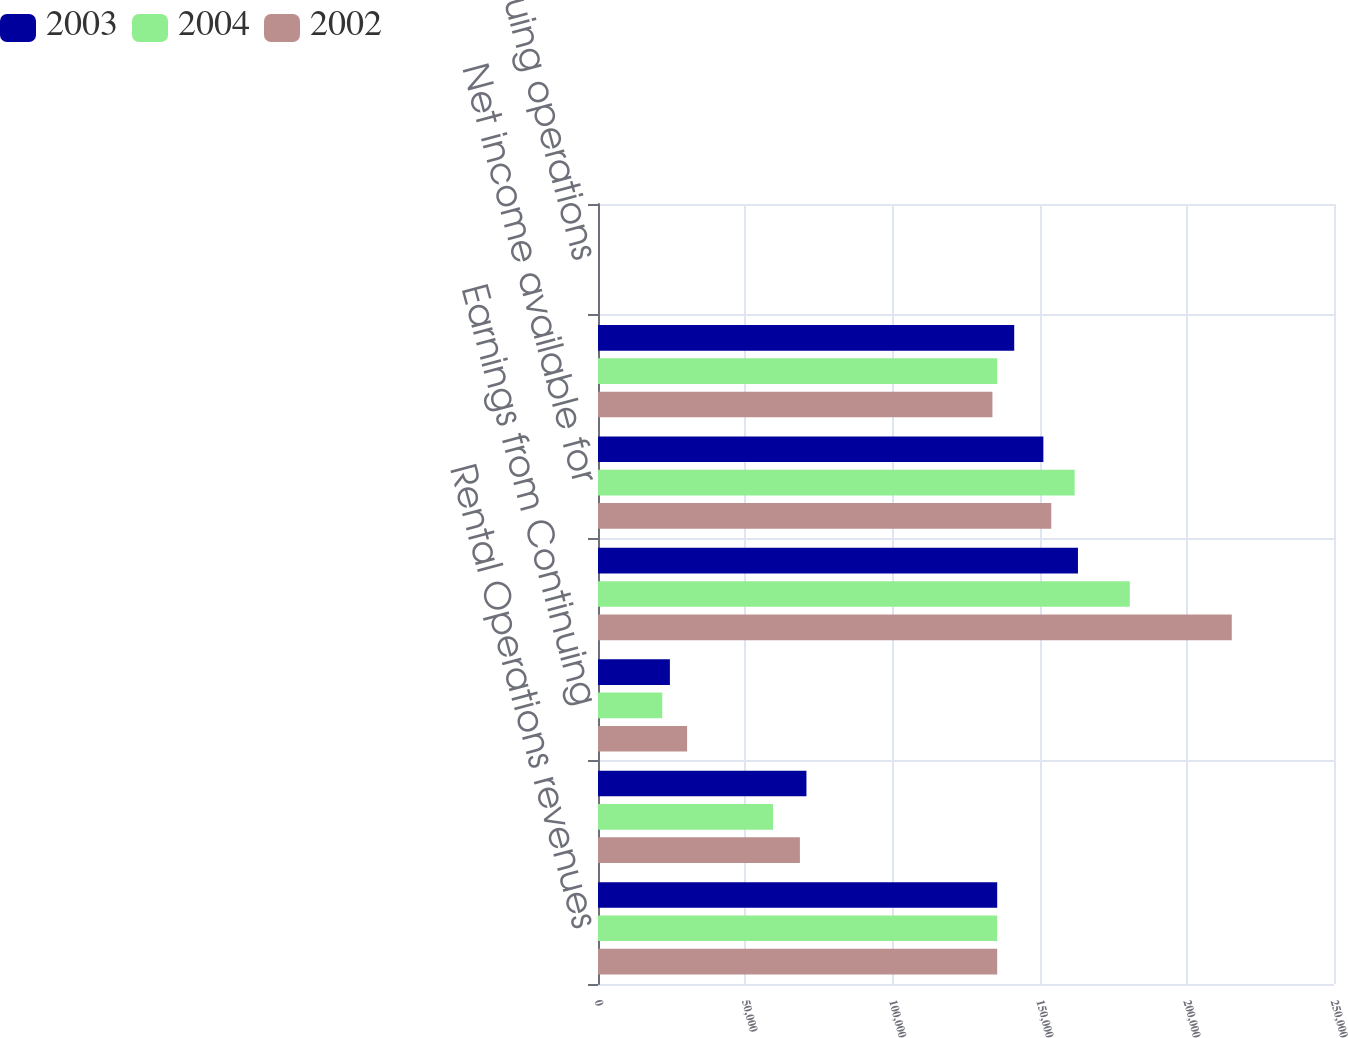<chart> <loc_0><loc_0><loc_500><loc_500><stacked_bar_chart><ecel><fcel>Rental Operations revenues<fcel>Service Operations revenues<fcel>Earnings from Continuing<fcel>Operating income<fcel>Net income available for<fcel>Weighted average common shares<fcel>Continuing operations<nl><fcel>2003<fcel>135595<fcel>70803<fcel>24421<fcel>163031<fcel>151279<fcel>141379<fcel>0.89<nl><fcel>2004<fcel>135595<fcel>59456<fcel>21821<fcel>180638<fcel>161911<fcel>135595<fcel>1.06<nl><fcel>2002<fcel>135595<fcel>68580<fcel>30270<fcel>215275<fcel>153969<fcel>133981<fcel>1.1<nl></chart> 